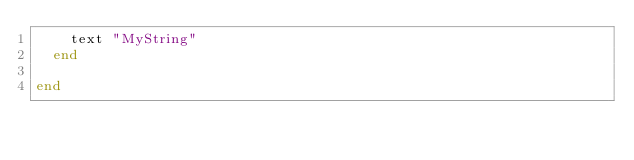<code> <loc_0><loc_0><loc_500><loc_500><_Ruby_>    text "MyString"
  end

end
</code> 